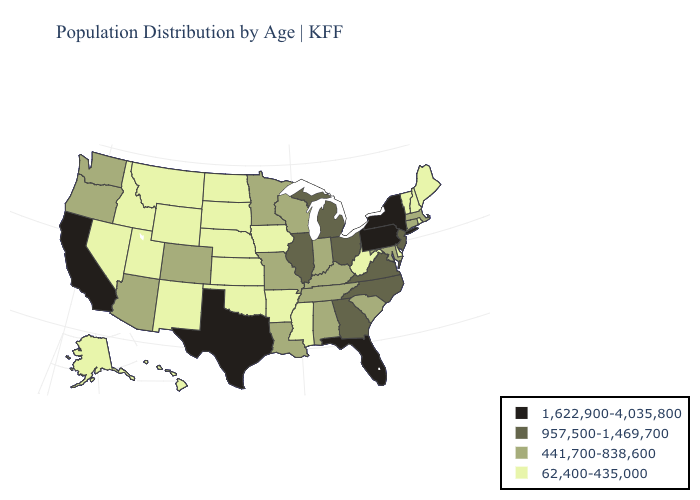What is the lowest value in states that border Wisconsin?
Answer briefly. 62,400-435,000. What is the value of Ohio?
Give a very brief answer. 957,500-1,469,700. Among the states that border Indiana , does Illinois have the lowest value?
Quick response, please. No. Does Kansas have the lowest value in the MidWest?
Quick response, please. Yes. What is the value of Virginia?
Give a very brief answer. 957,500-1,469,700. Does Texas have the highest value in the South?
Concise answer only. Yes. Among the states that border Colorado , which have the lowest value?
Give a very brief answer. Kansas, Nebraska, New Mexico, Oklahoma, Utah, Wyoming. Does the first symbol in the legend represent the smallest category?
Quick response, please. No. Name the states that have a value in the range 957,500-1,469,700?
Short answer required. Georgia, Illinois, Michigan, New Jersey, North Carolina, Ohio, Virginia. What is the value of Arkansas?
Keep it brief. 62,400-435,000. Does Arkansas have the lowest value in the South?
Concise answer only. Yes. Among the states that border Maine , which have the highest value?
Concise answer only. New Hampshire. What is the lowest value in states that border Vermont?
Keep it brief. 62,400-435,000. Which states hav the highest value in the MidWest?
Write a very short answer. Illinois, Michigan, Ohio. Does West Virginia have the same value as Wyoming?
Give a very brief answer. Yes. 